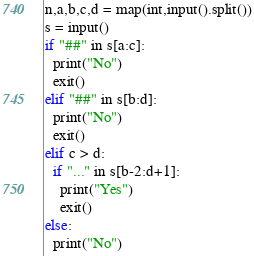<code> <loc_0><loc_0><loc_500><loc_500><_Python_>n,a,b,c,d = map(int,input().split())
s = input()
if "##" in s[a:c]:
  print("No")
  exit()
elif "##" in s[b:d]:
  print("No")
  exit()
elif c > d:
  if "..." in s[b-2:d+1]:
    print("Yes")
    exit()
else:
  print("No")
</code> 